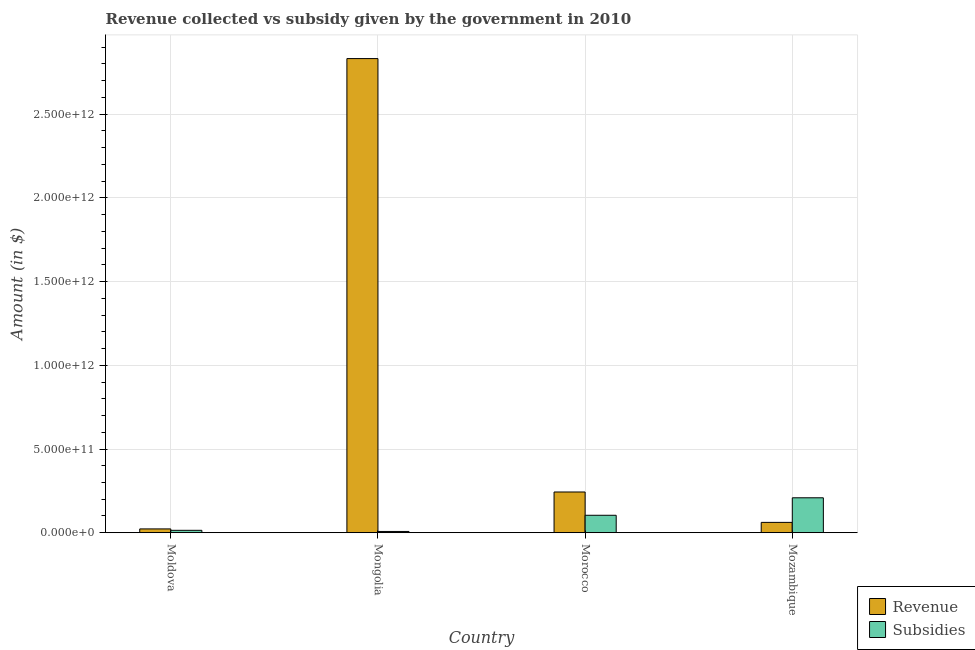How many groups of bars are there?
Give a very brief answer. 4. Are the number of bars on each tick of the X-axis equal?
Make the answer very short. Yes. How many bars are there on the 1st tick from the right?
Make the answer very short. 2. What is the label of the 2nd group of bars from the left?
Provide a succinct answer. Mongolia. What is the amount of subsidies given in Mongolia?
Ensure brevity in your answer.  7.49e+09. Across all countries, what is the maximum amount of revenue collected?
Offer a very short reply. 2.83e+12. Across all countries, what is the minimum amount of subsidies given?
Ensure brevity in your answer.  7.49e+09. In which country was the amount of subsidies given maximum?
Your response must be concise. Mozambique. In which country was the amount of revenue collected minimum?
Offer a very short reply. Moldova. What is the total amount of revenue collected in the graph?
Give a very brief answer. 3.16e+12. What is the difference between the amount of subsidies given in Mongolia and that in Mozambique?
Your answer should be compact. -2.01e+11. What is the difference between the amount of subsidies given in Mongolia and the amount of revenue collected in Mozambique?
Ensure brevity in your answer.  -5.42e+1. What is the average amount of revenue collected per country?
Make the answer very short. 7.90e+11. What is the difference between the amount of revenue collected and amount of subsidies given in Moldova?
Provide a succinct answer. 8.48e+09. What is the ratio of the amount of revenue collected in Moldova to that in Morocco?
Provide a short and direct response. 0.09. Is the amount of revenue collected in Morocco less than that in Mozambique?
Keep it short and to the point. No. Is the difference between the amount of subsidies given in Mongolia and Morocco greater than the difference between the amount of revenue collected in Mongolia and Morocco?
Provide a succinct answer. No. What is the difference between the highest and the second highest amount of subsidies given?
Offer a very short reply. 1.04e+11. What is the difference between the highest and the lowest amount of revenue collected?
Your response must be concise. 2.81e+12. Is the sum of the amount of subsidies given in Moldova and Mongolia greater than the maximum amount of revenue collected across all countries?
Give a very brief answer. No. What does the 2nd bar from the left in Mozambique represents?
Your answer should be compact. Subsidies. What does the 1st bar from the right in Morocco represents?
Your answer should be very brief. Subsidies. What is the difference between two consecutive major ticks on the Y-axis?
Make the answer very short. 5.00e+11. Are the values on the major ticks of Y-axis written in scientific E-notation?
Your answer should be very brief. Yes. Does the graph contain any zero values?
Your answer should be very brief. No. Does the graph contain grids?
Offer a terse response. Yes. How many legend labels are there?
Your answer should be compact. 2. What is the title of the graph?
Provide a succinct answer. Revenue collected vs subsidy given by the government in 2010. Does "Time to export" appear as one of the legend labels in the graph?
Keep it short and to the point. No. What is the label or title of the Y-axis?
Offer a terse response. Amount (in $). What is the Amount (in $) of Revenue in Moldova?
Make the answer very short. 2.27e+1. What is the Amount (in $) in Subsidies in Moldova?
Give a very brief answer. 1.42e+1. What is the Amount (in $) in Revenue in Mongolia?
Make the answer very short. 2.83e+12. What is the Amount (in $) of Subsidies in Mongolia?
Keep it short and to the point. 7.49e+09. What is the Amount (in $) of Revenue in Morocco?
Keep it short and to the point. 2.43e+11. What is the Amount (in $) of Subsidies in Morocco?
Your answer should be very brief. 1.04e+11. What is the Amount (in $) of Revenue in Mozambique?
Keep it short and to the point. 6.17e+1. What is the Amount (in $) in Subsidies in Mozambique?
Your answer should be compact. 2.09e+11. Across all countries, what is the maximum Amount (in $) in Revenue?
Provide a short and direct response. 2.83e+12. Across all countries, what is the maximum Amount (in $) in Subsidies?
Keep it short and to the point. 2.09e+11. Across all countries, what is the minimum Amount (in $) of Revenue?
Offer a very short reply. 2.27e+1. Across all countries, what is the minimum Amount (in $) of Subsidies?
Your answer should be compact. 7.49e+09. What is the total Amount (in $) of Revenue in the graph?
Give a very brief answer. 3.16e+12. What is the total Amount (in $) in Subsidies in the graph?
Offer a very short reply. 3.35e+11. What is the difference between the Amount (in $) in Revenue in Moldova and that in Mongolia?
Provide a short and direct response. -2.81e+12. What is the difference between the Amount (in $) of Subsidies in Moldova and that in Mongolia?
Provide a short and direct response. 6.75e+09. What is the difference between the Amount (in $) in Revenue in Moldova and that in Morocco?
Keep it short and to the point. -2.21e+11. What is the difference between the Amount (in $) of Subsidies in Moldova and that in Morocco?
Provide a succinct answer. -8.99e+1. What is the difference between the Amount (in $) in Revenue in Moldova and that in Mozambique?
Give a very brief answer. -3.90e+1. What is the difference between the Amount (in $) in Subsidies in Moldova and that in Mozambique?
Ensure brevity in your answer.  -1.94e+11. What is the difference between the Amount (in $) of Revenue in Mongolia and that in Morocco?
Keep it short and to the point. 2.59e+12. What is the difference between the Amount (in $) in Subsidies in Mongolia and that in Morocco?
Offer a terse response. -9.67e+1. What is the difference between the Amount (in $) in Revenue in Mongolia and that in Mozambique?
Provide a short and direct response. 2.77e+12. What is the difference between the Amount (in $) of Subsidies in Mongolia and that in Mozambique?
Offer a terse response. -2.01e+11. What is the difference between the Amount (in $) of Revenue in Morocco and that in Mozambique?
Offer a terse response. 1.82e+11. What is the difference between the Amount (in $) in Subsidies in Morocco and that in Mozambique?
Your answer should be compact. -1.04e+11. What is the difference between the Amount (in $) in Revenue in Moldova and the Amount (in $) in Subsidies in Mongolia?
Give a very brief answer. 1.52e+1. What is the difference between the Amount (in $) of Revenue in Moldova and the Amount (in $) of Subsidies in Morocco?
Your answer should be very brief. -8.15e+1. What is the difference between the Amount (in $) in Revenue in Moldova and the Amount (in $) in Subsidies in Mozambique?
Give a very brief answer. -1.86e+11. What is the difference between the Amount (in $) in Revenue in Mongolia and the Amount (in $) in Subsidies in Morocco?
Make the answer very short. 2.73e+12. What is the difference between the Amount (in $) of Revenue in Mongolia and the Amount (in $) of Subsidies in Mozambique?
Provide a short and direct response. 2.62e+12. What is the difference between the Amount (in $) in Revenue in Morocco and the Amount (in $) in Subsidies in Mozambique?
Provide a short and direct response. 3.46e+1. What is the average Amount (in $) in Revenue per country?
Offer a terse response. 7.90e+11. What is the average Amount (in $) in Subsidies per country?
Ensure brevity in your answer.  8.36e+1. What is the difference between the Amount (in $) in Revenue and Amount (in $) in Subsidies in Moldova?
Provide a succinct answer. 8.48e+09. What is the difference between the Amount (in $) of Revenue and Amount (in $) of Subsidies in Mongolia?
Make the answer very short. 2.82e+12. What is the difference between the Amount (in $) of Revenue and Amount (in $) of Subsidies in Morocco?
Provide a short and direct response. 1.39e+11. What is the difference between the Amount (in $) in Revenue and Amount (in $) in Subsidies in Mozambique?
Ensure brevity in your answer.  -1.47e+11. What is the ratio of the Amount (in $) in Revenue in Moldova to that in Mongolia?
Your response must be concise. 0.01. What is the ratio of the Amount (in $) of Subsidies in Moldova to that in Mongolia?
Provide a succinct answer. 1.9. What is the ratio of the Amount (in $) in Revenue in Moldova to that in Morocco?
Offer a very short reply. 0.09. What is the ratio of the Amount (in $) in Subsidies in Moldova to that in Morocco?
Ensure brevity in your answer.  0.14. What is the ratio of the Amount (in $) in Revenue in Moldova to that in Mozambique?
Keep it short and to the point. 0.37. What is the ratio of the Amount (in $) in Subsidies in Moldova to that in Mozambique?
Give a very brief answer. 0.07. What is the ratio of the Amount (in $) of Revenue in Mongolia to that in Morocco?
Your answer should be compact. 11.64. What is the ratio of the Amount (in $) of Subsidies in Mongolia to that in Morocco?
Offer a very short reply. 0.07. What is the ratio of the Amount (in $) in Revenue in Mongolia to that in Mozambique?
Your answer should be very brief. 45.9. What is the ratio of the Amount (in $) in Subsidies in Mongolia to that in Mozambique?
Provide a succinct answer. 0.04. What is the ratio of the Amount (in $) in Revenue in Morocco to that in Mozambique?
Give a very brief answer. 3.94. What is the ratio of the Amount (in $) of Subsidies in Morocco to that in Mozambique?
Make the answer very short. 0.5. What is the difference between the highest and the second highest Amount (in $) of Revenue?
Make the answer very short. 2.59e+12. What is the difference between the highest and the second highest Amount (in $) in Subsidies?
Provide a short and direct response. 1.04e+11. What is the difference between the highest and the lowest Amount (in $) in Revenue?
Keep it short and to the point. 2.81e+12. What is the difference between the highest and the lowest Amount (in $) of Subsidies?
Your response must be concise. 2.01e+11. 